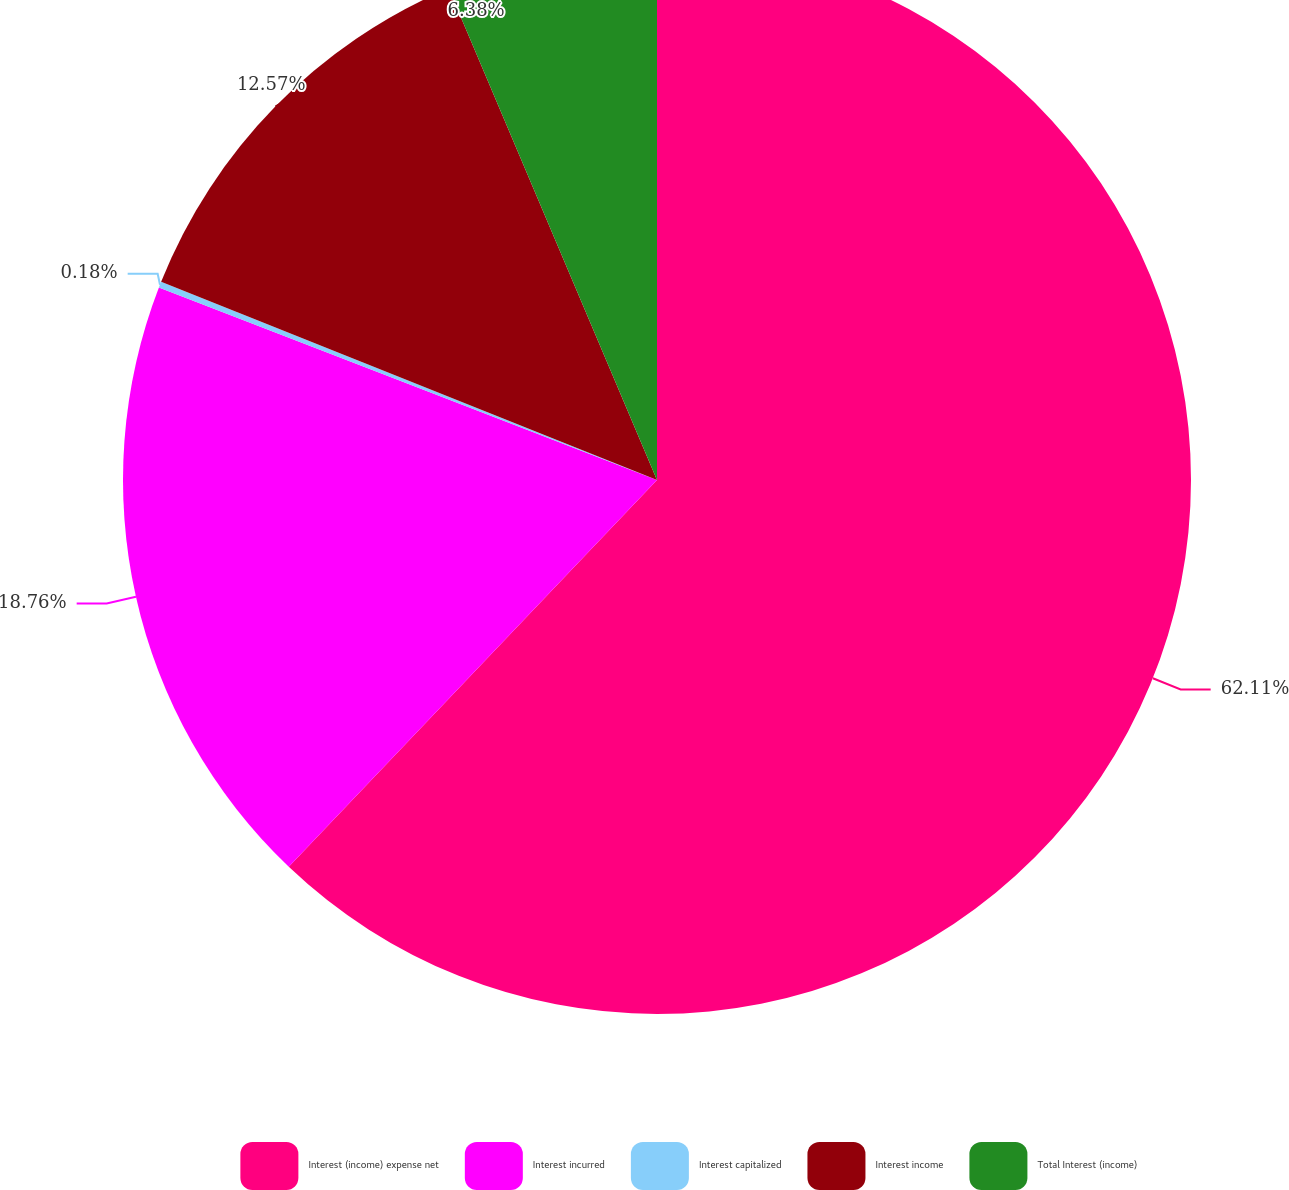Convert chart. <chart><loc_0><loc_0><loc_500><loc_500><pie_chart><fcel>Interest (income) expense net<fcel>Interest incurred<fcel>Interest capitalized<fcel>Interest income<fcel>Total Interest (income)<nl><fcel>62.11%<fcel>18.76%<fcel>0.18%<fcel>12.57%<fcel>6.38%<nl></chart> 